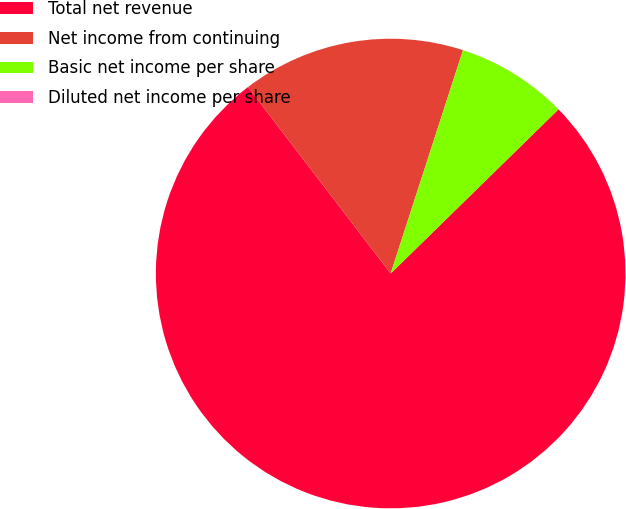Convert chart to OTSL. <chart><loc_0><loc_0><loc_500><loc_500><pie_chart><fcel>Total net revenue<fcel>Net income from continuing<fcel>Basic net income per share<fcel>Diluted net income per share<nl><fcel>76.92%<fcel>15.38%<fcel>7.69%<fcel>0.0%<nl></chart> 